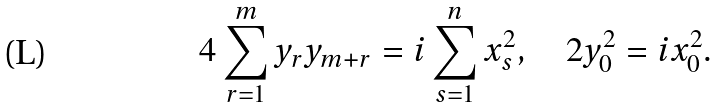<formula> <loc_0><loc_0><loc_500><loc_500>4 \sum _ { r = 1 } ^ { m } y _ { r } y _ { m + r } = i \sum _ { s = 1 } ^ { n } x _ { s } ^ { 2 } , \quad 2 y _ { 0 } ^ { 2 } = i x _ { 0 } ^ { 2 } .</formula> 